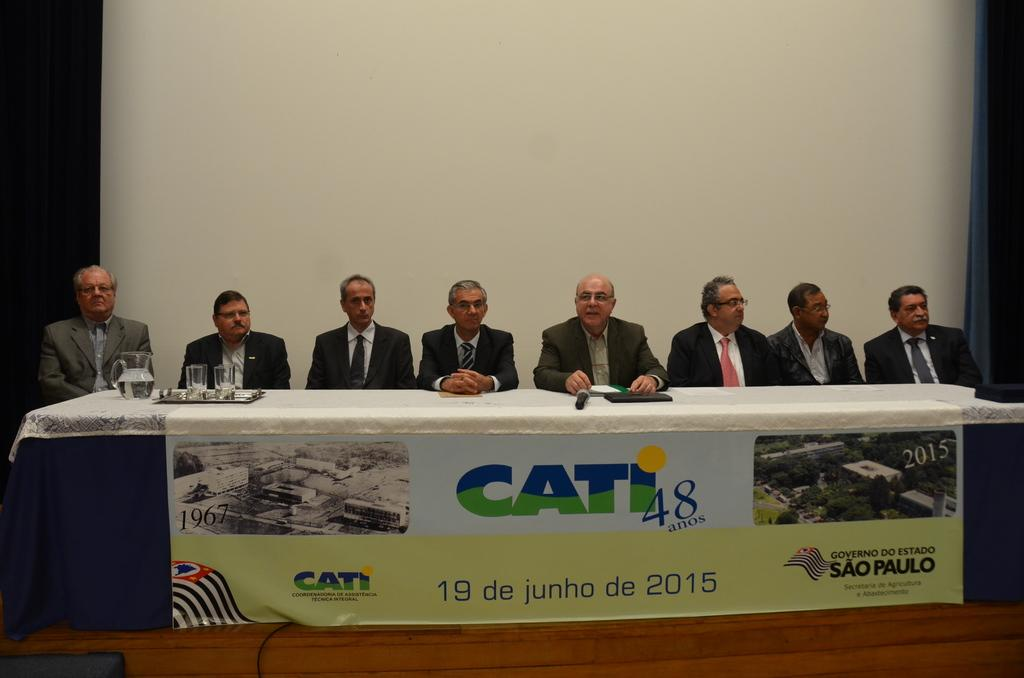What are the people in the image doing? There is a group of people sitting in the image. What object can be used for serving liquids in the image? There is a jug in the image. What items are present for holding drinks in the image? There are glasses on a tray in the image. What device is used for amplifying sound in the image? There is a microphone (mike) in the image. What objects are related to learning or reading in the image? There are books on a table in the image. What is visible in the background of the image? There is a wall in the background of the image. How many sheep are visible in the image? There are no sheep present in the image. What type of test is being conducted in the image? There is no test being conducted in the image. 